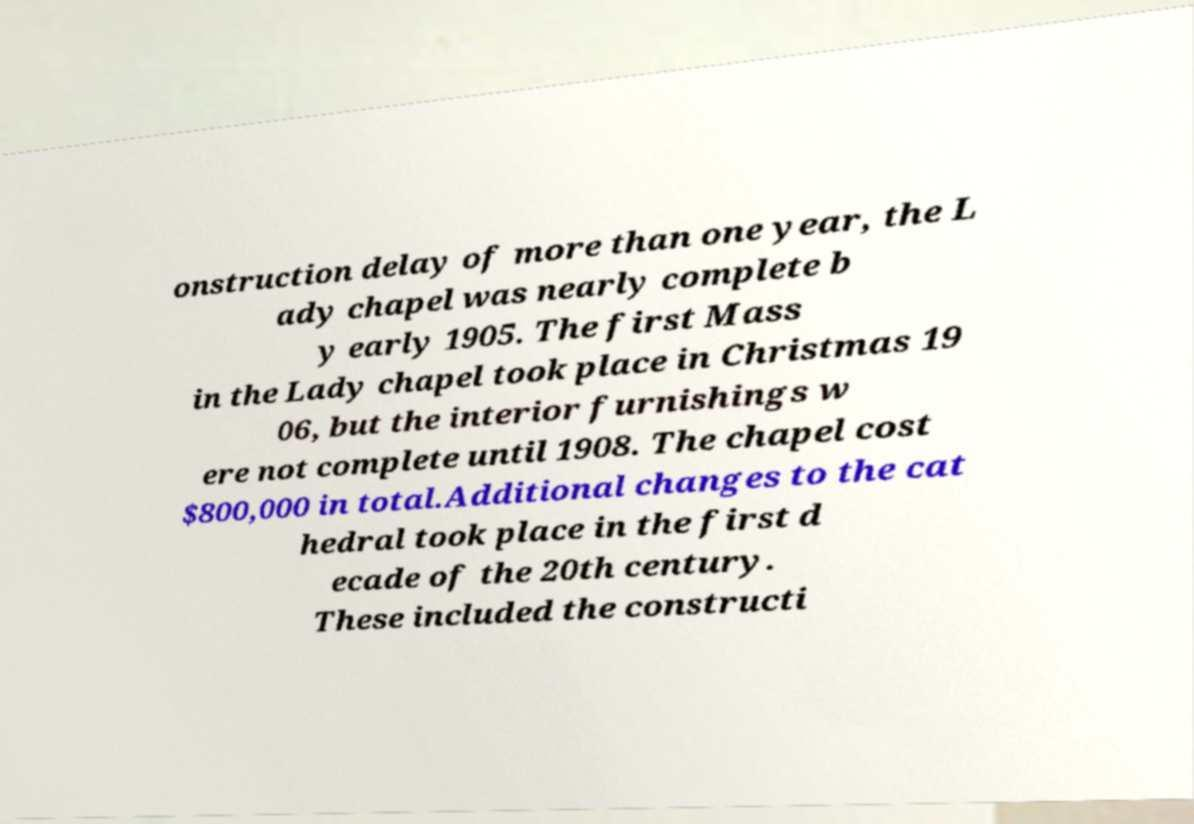Can you accurately transcribe the text from the provided image for me? onstruction delay of more than one year, the L ady chapel was nearly complete b y early 1905. The first Mass in the Lady chapel took place in Christmas 19 06, but the interior furnishings w ere not complete until 1908. The chapel cost $800,000 in total.Additional changes to the cat hedral took place in the first d ecade of the 20th century. These included the constructi 